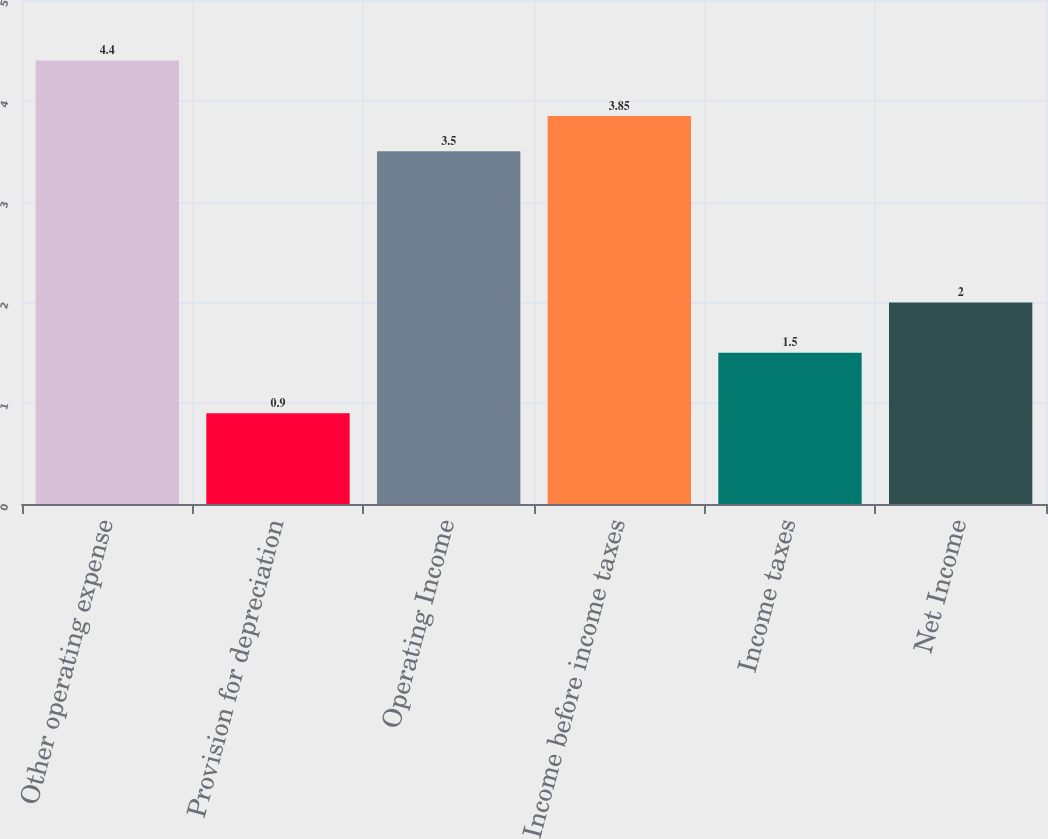Convert chart to OTSL. <chart><loc_0><loc_0><loc_500><loc_500><bar_chart><fcel>Other operating expense<fcel>Provision for depreciation<fcel>Operating Income<fcel>Income before income taxes<fcel>Income taxes<fcel>Net Income<nl><fcel>4.4<fcel>0.9<fcel>3.5<fcel>3.85<fcel>1.5<fcel>2<nl></chart> 